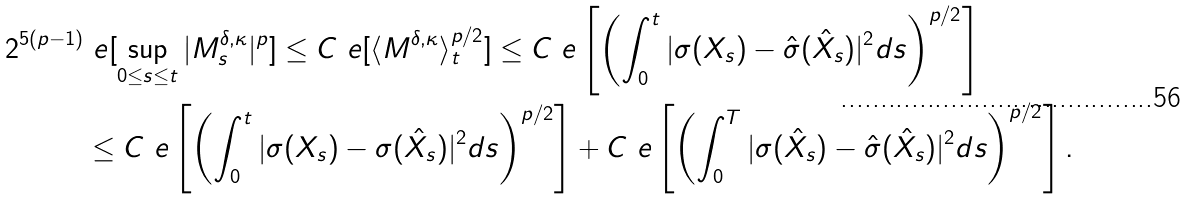<formula> <loc_0><loc_0><loc_500><loc_500>2 ^ { 5 ( p - 1 ) } & \ e [ \sup _ { 0 \leq s \leq t } | M _ { s } ^ { \delta , \kappa } | ^ { p } ] \leq C \ e [ \langle M ^ { \delta , \kappa } \rangle _ { t } ^ { p / 2 } ] \leq C \ e \left [ \left ( \int _ { 0 } ^ { t } | { \sigma } ( X _ { s } ) - \hat { \sigma } ( \hat { X } _ { s } ) | ^ { 2 } d s \right ) ^ { p / 2 } \right ] \\ & \leq C \ e \left [ \left ( \int _ { 0 } ^ { t } | { \sigma } ( X _ { s } ) - { \sigma } ( \hat { X } _ { s } ) | ^ { 2 } d s \right ) ^ { p / 2 } \right ] + C \ e \left [ \left ( \int _ { 0 } ^ { T } | { \sigma } ( \hat { X } _ { s } ) - \hat { \sigma } ( \hat { X } _ { s } ) | ^ { 2 } d s \right ) ^ { p / 2 } \right ] .</formula> 